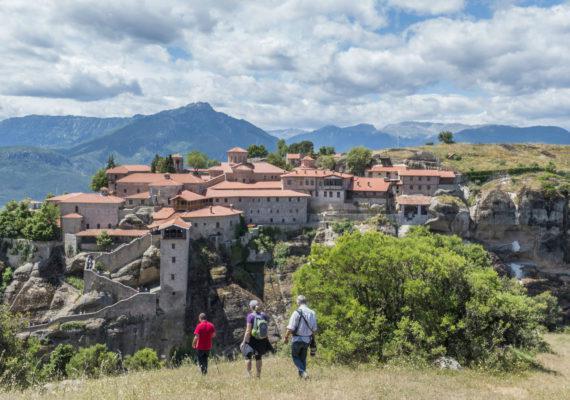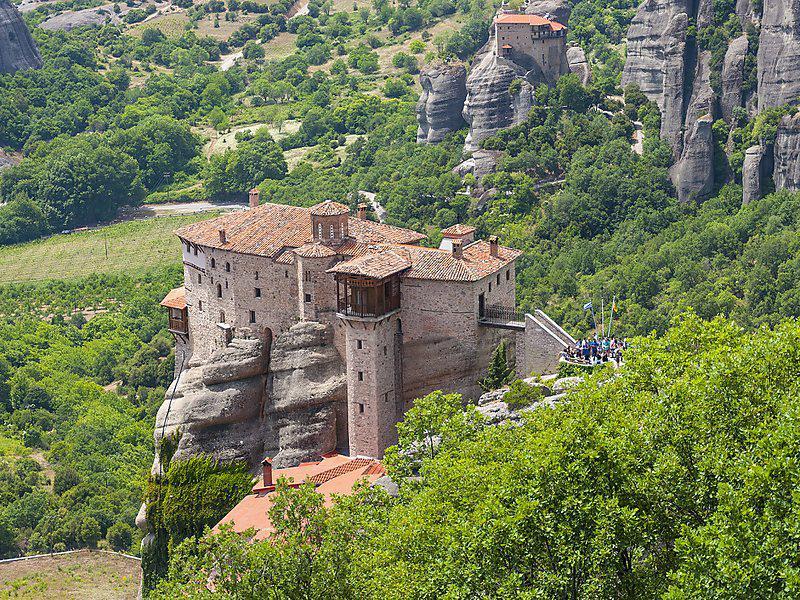The first image is the image on the left, the second image is the image on the right. Given the left and right images, does the statement "In at least one image there is a peach building built in to the top of the rocks with one tower that is topped with a open wooden balcony." hold true? Answer yes or no. Yes. 